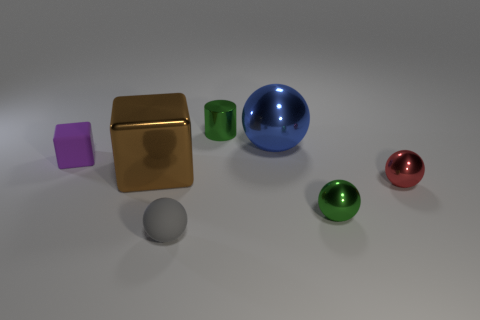Is there a cyan metal cylinder that has the same size as the red metal ball?
Ensure brevity in your answer.  No. Is the number of big blue objects greater than the number of big red metal cylinders?
Provide a succinct answer. Yes. There is a object left of the large shiny cube; is it the same size as the sphere that is to the left of the green cylinder?
Keep it short and to the point. Yes. What number of objects are both on the right side of the cylinder and in front of the brown object?
Offer a terse response. 2. The small matte thing that is the same shape as the brown shiny object is what color?
Keep it short and to the point. Purple. Are there fewer red shiny balls than gray blocks?
Ensure brevity in your answer.  No. Does the matte sphere have the same size as the green metal object that is behind the red object?
Your answer should be compact. Yes. There is a sphere that is on the left side of the large object on the right side of the tiny cylinder; what color is it?
Your response must be concise. Gray. How many things are either matte things that are behind the brown metallic block or large brown blocks that are left of the tiny cylinder?
Your answer should be compact. 2. Is the blue ball the same size as the brown metallic cube?
Provide a short and direct response. Yes. 